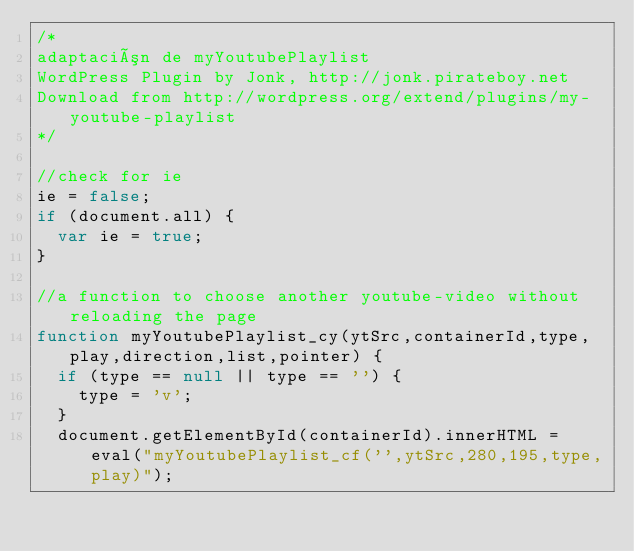Convert code to text. <code><loc_0><loc_0><loc_500><loc_500><_JavaScript_>/*
adaptación de myYoutubePlaylist
WordPress Plugin by Jonk, http://jonk.pirateboy.net
Download from http://wordpress.org/extend/plugins/my-youtube-playlist
*/

//check for ie
ie = false;
if (document.all) {
	var ie = true;
}

//a function to choose another youtube-video without reloading the page
function myYoutubePlaylist_cy(ytSrc,containerId,type,play,direction,list,pointer) {
	if (type == null || type == '') {
		type = 'v';
	}
	document.getElementById(containerId).innerHTML = eval("myYoutubePlaylist_cf('',ytSrc,280,195,type,play)");</code> 